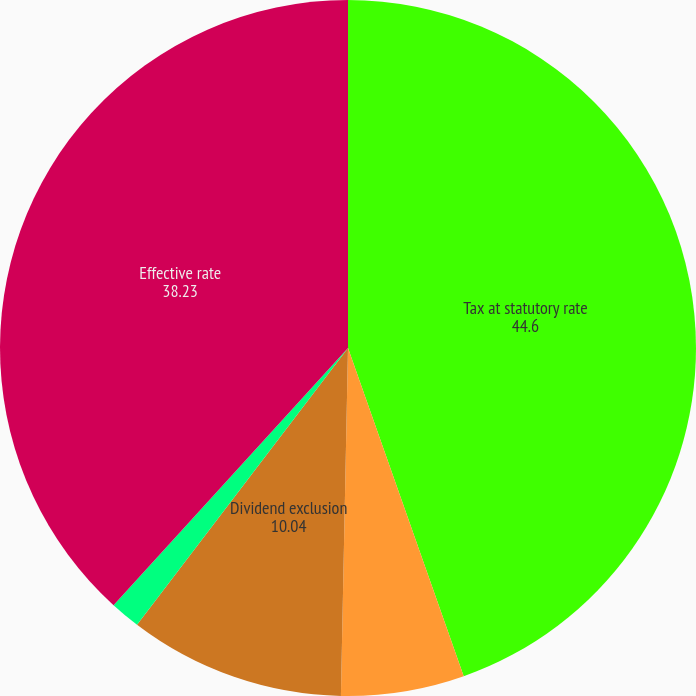<chart> <loc_0><loc_0><loc_500><loc_500><pie_chart><fcel>Tax at statutory rate<fcel>Tax-exempt municipal bonds<fcel>Dividend exclusion<fcel>Other<fcel>Effective rate<nl><fcel>44.6%<fcel>5.72%<fcel>10.04%<fcel>1.4%<fcel>38.23%<nl></chart> 